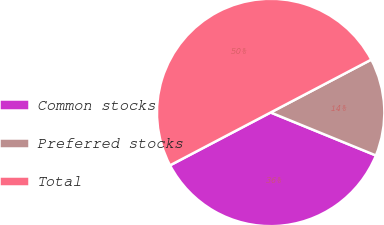Convert chart. <chart><loc_0><loc_0><loc_500><loc_500><pie_chart><fcel>Common stocks<fcel>Preferred stocks<fcel>Total<nl><fcel>36.13%<fcel>13.87%<fcel>50.0%<nl></chart> 